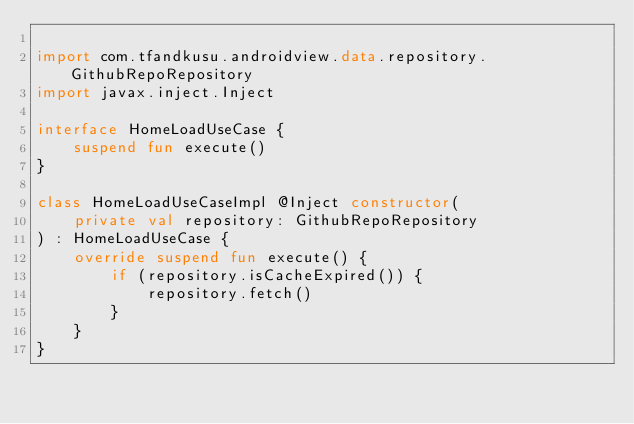<code> <loc_0><loc_0><loc_500><loc_500><_Kotlin_>
import com.tfandkusu.androidview.data.repository.GithubRepoRepository
import javax.inject.Inject

interface HomeLoadUseCase {
    suspend fun execute()
}

class HomeLoadUseCaseImpl @Inject constructor(
    private val repository: GithubRepoRepository
) : HomeLoadUseCase {
    override suspend fun execute() {
        if (repository.isCacheExpired()) {
            repository.fetch()
        }
    }
}
</code> 